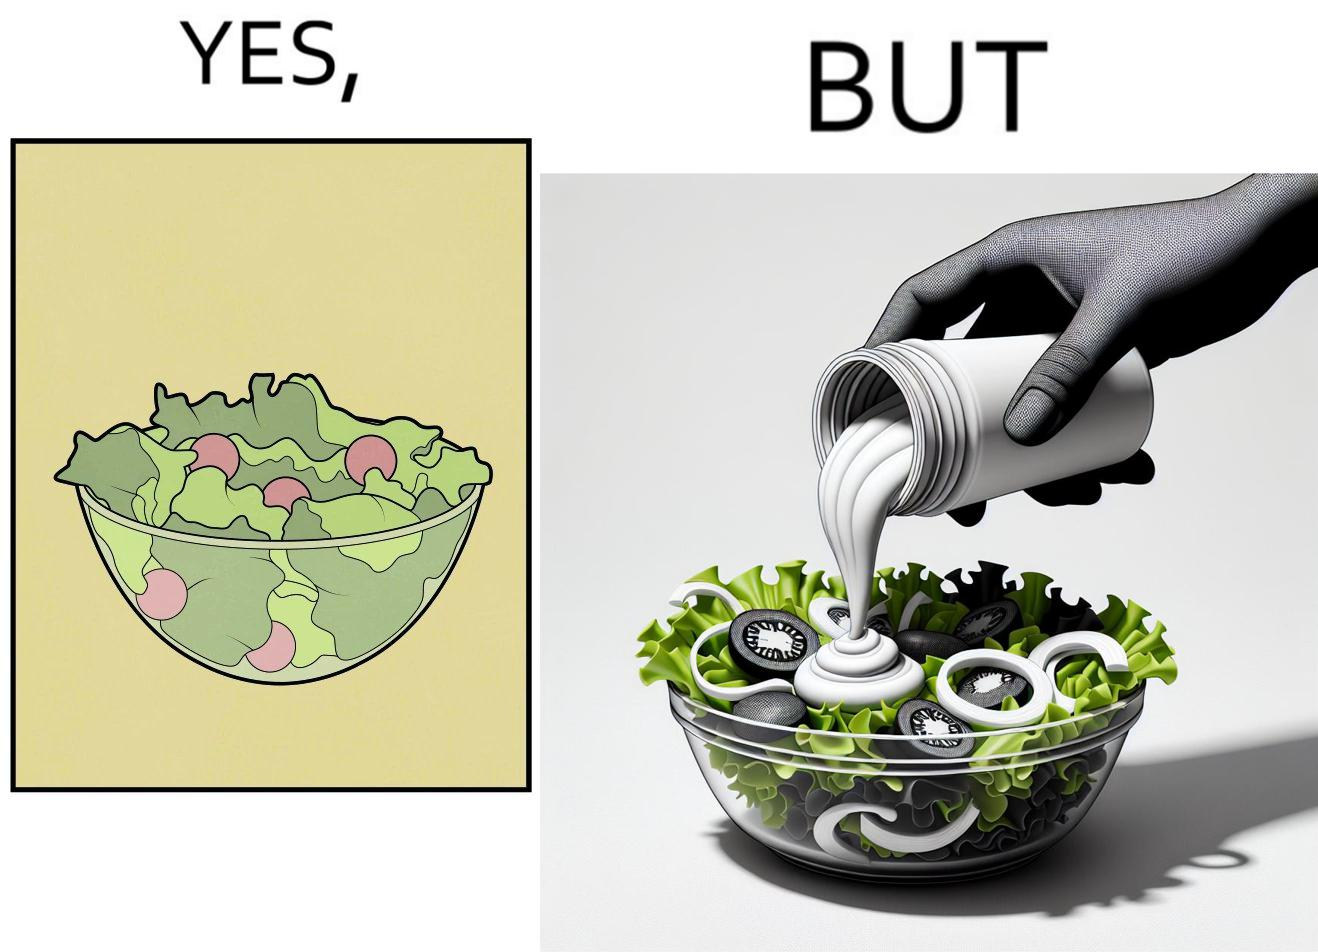Why is this image considered satirical? The image is ironical, as salad in a bowl by itself is very healthy. However, when people have it with Mayonnaise sauce to improve the taste, it is not healthy anymore, and defeats the point of having nutrient-rich salad altogether. 